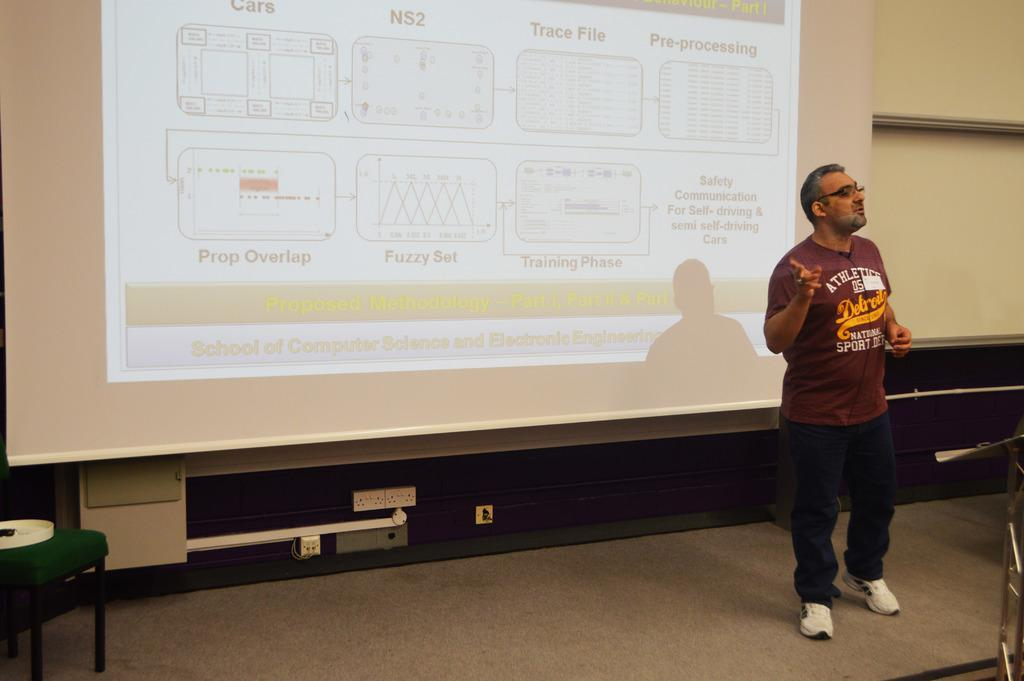<image>
Give a short and clear explanation of the subsequent image. Safety communication for self driving cars is the title of the presentation. 